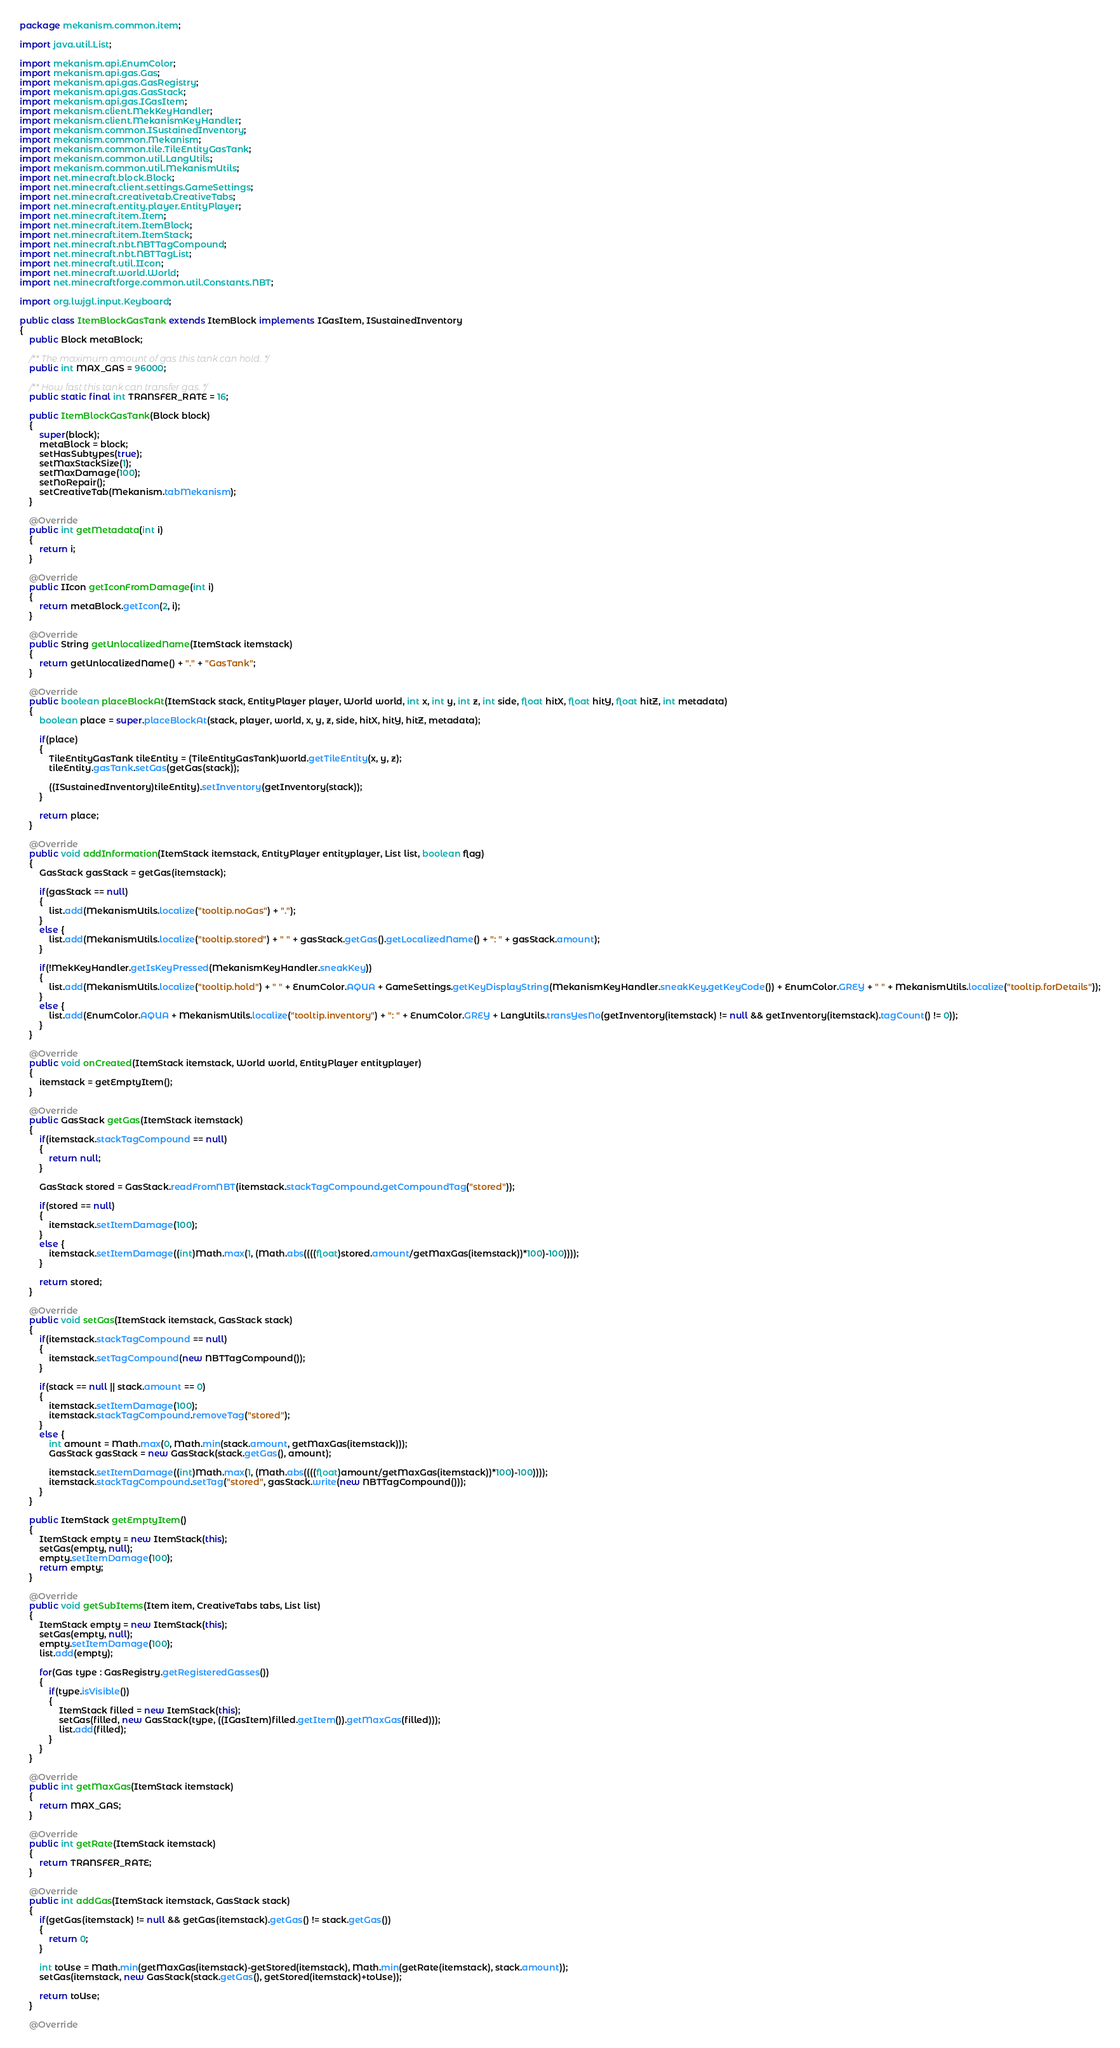Convert code to text. <code><loc_0><loc_0><loc_500><loc_500><_Java_>package mekanism.common.item;

import java.util.List;

import mekanism.api.EnumColor;
import mekanism.api.gas.Gas;
import mekanism.api.gas.GasRegistry;
import mekanism.api.gas.GasStack;
import mekanism.api.gas.IGasItem;
import mekanism.client.MekKeyHandler;
import mekanism.client.MekanismKeyHandler;
import mekanism.common.ISustainedInventory;
import mekanism.common.Mekanism;
import mekanism.common.tile.TileEntityGasTank;
import mekanism.common.util.LangUtils;
import mekanism.common.util.MekanismUtils;
import net.minecraft.block.Block;
import net.minecraft.client.settings.GameSettings;
import net.minecraft.creativetab.CreativeTabs;
import net.minecraft.entity.player.EntityPlayer;
import net.minecraft.item.Item;
import net.minecraft.item.ItemBlock;
import net.minecraft.item.ItemStack;
import net.minecraft.nbt.NBTTagCompound;
import net.minecraft.nbt.NBTTagList;
import net.minecraft.util.IIcon;
import net.minecraft.world.World;
import net.minecraftforge.common.util.Constants.NBT;

import org.lwjgl.input.Keyboard;

public class ItemBlockGasTank extends ItemBlock implements IGasItem, ISustainedInventory
{
	public Block metaBlock;

	/** The maximum amount of gas this tank can hold. */
	public int MAX_GAS = 96000;

	/** How fast this tank can transfer gas. */
	public static final int TRANSFER_RATE = 16;

	public ItemBlockGasTank(Block block)
	{
		super(block);
		metaBlock = block;
		setHasSubtypes(true);
		setMaxStackSize(1);
		setMaxDamage(100);
		setNoRepair();
		setCreativeTab(Mekanism.tabMekanism);
	}

	@Override
	public int getMetadata(int i)
	{
		return i;
	}

	@Override
	public IIcon getIconFromDamage(int i)
	{
		return metaBlock.getIcon(2, i);
	}

	@Override
	public String getUnlocalizedName(ItemStack itemstack)
	{
		return getUnlocalizedName() + "." + "GasTank";
	}

	@Override
	public boolean placeBlockAt(ItemStack stack, EntityPlayer player, World world, int x, int y, int z, int side, float hitX, float hitY, float hitZ, int metadata)
	{
		boolean place = super.placeBlockAt(stack, player, world, x, y, z, side, hitX, hitY, hitZ, metadata);

		if(place)
		{
			TileEntityGasTank tileEntity = (TileEntityGasTank)world.getTileEntity(x, y, z);
			tileEntity.gasTank.setGas(getGas(stack));

			((ISustainedInventory)tileEntity).setInventory(getInventory(stack));
		}

		return place;
	}

	@Override
	public void addInformation(ItemStack itemstack, EntityPlayer entityplayer, List list, boolean flag)
	{
		GasStack gasStack = getGas(itemstack);

		if(gasStack == null)
		{
			list.add(MekanismUtils.localize("tooltip.noGas") + ".");
		}
		else {
			list.add(MekanismUtils.localize("tooltip.stored") + " " + gasStack.getGas().getLocalizedName() + ": " + gasStack.amount);
		}

		if(!MekKeyHandler.getIsKeyPressed(MekanismKeyHandler.sneakKey))
		{
			list.add(MekanismUtils.localize("tooltip.hold") + " " + EnumColor.AQUA + GameSettings.getKeyDisplayString(MekanismKeyHandler.sneakKey.getKeyCode()) + EnumColor.GREY + " " + MekanismUtils.localize("tooltip.forDetails"));
		}
		else {
			list.add(EnumColor.AQUA + MekanismUtils.localize("tooltip.inventory") + ": " + EnumColor.GREY + LangUtils.transYesNo(getInventory(itemstack) != null && getInventory(itemstack).tagCount() != 0));
		}
	}

	@Override
	public void onCreated(ItemStack itemstack, World world, EntityPlayer entityplayer)
	{
		itemstack = getEmptyItem();
	}

	@Override
	public GasStack getGas(ItemStack itemstack)
	{
		if(itemstack.stackTagCompound == null)
		{
			return null;
		}

		GasStack stored = GasStack.readFromNBT(itemstack.stackTagCompound.getCompoundTag("stored"));

		if(stored == null)
		{
			itemstack.setItemDamage(100);
		}
		else {
			itemstack.setItemDamage((int)Math.max(1, (Math.abs((((float)stored.amount/getMaxGas(itemstack))*100)-100))));
		}

		return stored;
	}

	@Override
	public void setGas(ItemStack itemstack, GasStack stack)
	{
		if(itemstack.stackTagCompound == null)
		{
			itemstack.setTagCompound(new NBTTagCompound());
		}

		if(stack == null || stack.amount == 0)
		{
			itemstack.setItemDamage(100);
			itemstack.stackTagCompound.removeTag("stored");
		}
		else {
			int amount = Math.max(0, Math.min(stack.amount, getMaxGas(itemstack)));
			GasStack gasStack = new GasStack(stack.getGas(), amount);

			itemstack.setItemDamage((int)Math.max(1, (Math.abs((((float)amount/getMaxGas(itemstack))*100)-100))));
			itemstack.stackTagCompound.setTag("stored", gasStack.write(new NBTTagCompound()));
		}
	}

	public ItemStack getEmptyItem()
	{
		ItemStack empty = new ItemStack(this);
		setGas(empty, null);
		empty.setItemDamage(100);
		return empty;
	}

	@Override
	public void getSubItems(Item item, CreativeTabs tabs, List list)
	{
		ItemStack empty = new ItemStack(this);
		setGas(empty, null);
		empty.setItemDamage(100);
		list.add(empty);

		for(Gas type : GasRegistry.getRegisteredGasses())
		{
			if(type.isVisible())
			{
				ItemStack filled = new ItemStack(this);
				setGas(filled, new GasStack(type, ((IGasItem)filled.getItem()).getMaxGas(filled)));
				list.add(filled);
			}
		}
	}

	@Override
	public int getMaxGas(ItemStack itemstack)
	{
		return MAX_GAS;
	}

	@Override
	public int getRate(ItemStack itemstack)
	{
		return TRANSFER_RATE;
	}

	@Override
	public int addGas(ItemStack itemstack, GasStack stack)
	{
		if(getGas(itemstack) != null && getGas(itemstack).getGas() != stack.getGas())
		{
			return 0;
		}

		int toUse = Math.min(getMaxGas(itemstack)-getStored(itemstack), Math.min(getRate(itemstack), stack.amount));
		setGas(itemstack, new GasStack(stack.getGas(), getStored(itemstack)+toUse));

		return toUse;
	}

	@Override</code> 